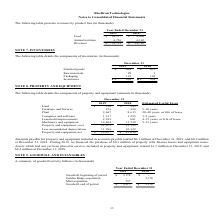From Ricebran Technologies's financial document, What are the respective goodwill at the end of the period in 2018 and 2019? The document shows two values: $3,178 and $3,915 (in thousands). From the document: "Goodwill, end of period 3,915 $ 3,178 $ Goodwill, beginning of period 3,178 $ - $..." Also, What is the value of the goodwill from the Golden Ridge acquisition in 2018? According to the financial document, 3,178 (in thousands). The relevant text states: "Goodwill, beginning of period 3,178 $ - $..." Also, What is the value of the goodwill from the MGI acquisition in 2019? According to the financial document, 737 (in thousands). The relevant text states: "MGI acquistion 737 -..." Also, can you calculate: What is the percentage change in goodwill at the end of the period at 2018 and 2019? To answer this question, I need to perform calculations using the financial data. The calculation is: (3,915 - 3,178)/3,178 , which equals 23.19 (percentage). This is based on the information: "Goodwill, end of period 3,915 $ 3,178 $ Goodwill, beginning of period 3,178 $ - $..." The key data points involved are: 3,178, 3,915. Also, can you calculate: What is the total goodwill obtained from acquisitions in 2018 and 2019? Based on the calculation: 3,178 + 737 , the result is 3915 (in thousands). This is based on the information: "Goodwill, beginning of period 3,178 $ - $ MGI acquistion 737 -..." The key data points involved are: 3,178, 737. Also, can you calculate: What is the difference in goodwill between the acquisitions made in 2018 and 2019? Based on the calculation: 3,178 - 737 , the result is 2441 (in thousands). This is based on the information: "Goodwill, beginning of period 3,178 $ - $ MGI acquistion 737 -..." The key data points involved are: 3,178, 737. 